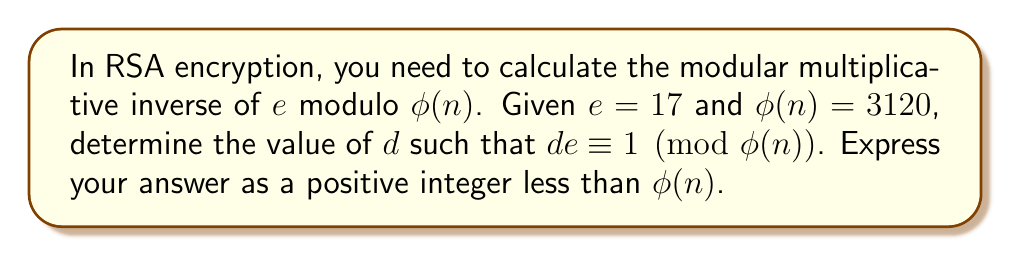Help me with this question. To find the modular multiplicative inverse, we can use the extended Euclidean algorithm. This algorithm finds the greatest common divisor (GCD) of two numbers and expresses it as a linear combination of these numbers. In Python, we could implement this as follows:

1) First, define the extended Euclidean algorithm function:

```python
def extended_gcd(a, b):
    if a == 0:
        return b, 0, 1
    else:
        gcd, x, y = extended_gcd(b % a, a)
        return gcd, y - (b // a) * x, x
```

2) Now, use this function to find the modular multiplicative inverse:

```python
e = 17
phi_n = 3120

gcd, x, y = extended_gcd(e, phi_n)

if gcd != 1:
    raise ValueError("Modular inverse does not exist")

d = x % phi_n
```

3) Let's break down the steps:

   - We call `extended_gcd(17, 3120)`
   - This returns `(1, -367, 2)`, meaning:
     $$1 = 17 \cdot (-367) + 3120 \cdot 2$$

4) The value we want is $x = -367$, but we need to ensure it's positive and less than $\phi(n)$:

   $$d = -367 \mod 3120 = 2753$$

5) We can verify this result:

   $$17 \cdot 2753 = 46801 \equiv 1 \pmod{3120}$$

Thus, the modular multiplicative inverse of 17 modulo 3120 is 2753.
Answer: 2753 